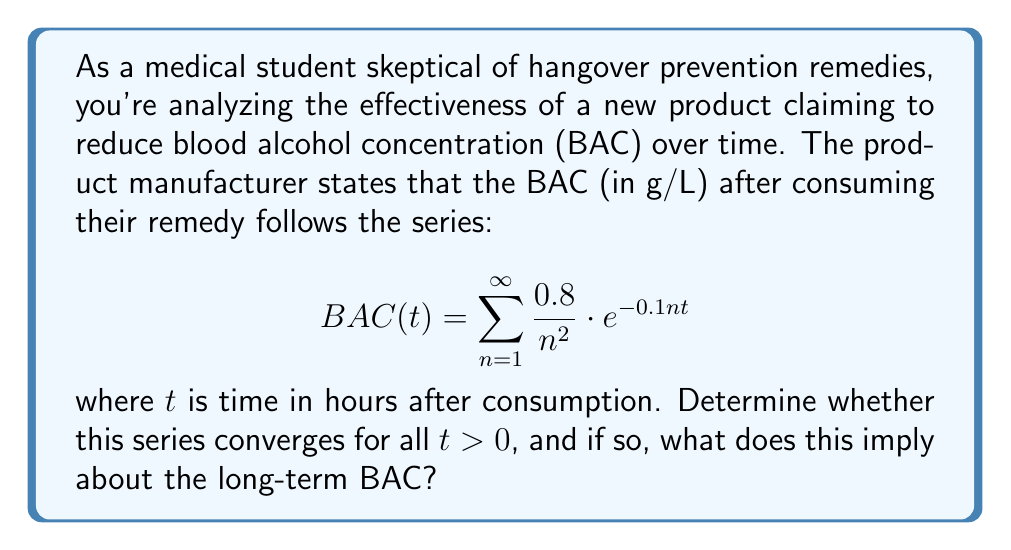Could you help me with this problem? Let's approach this step-by-step:

1) First, we need to check if the series converges for all $t > 0$. We can use the comparison test.

2) Observe that for any $t > 0$:
   
   $$0 < e^{-0.1nt} \leq 1$$

3) Therefore, we can compare our series with:
   
   $$\sum_{n=1}^{\infty} \frac{0.8}{n^2}$$

4) This is a p-series with $p = 2 > 1$, which is known to converge. Its sum is actually $\frac{\pi^2}{6}$.

5) By the comparison test, since $\frac{0.8}{n^2} \cdot e^{-0.1nt} \leq \frac{0.8}{n^2}$ for all $n$ and $t > 0$, and $\sum_{n=1}^{\infty} \frac{0.8}{n^2}$ converges, our original series must also converge for all $t > 0$.

6) The convergence of this series implies that the BAC has a finite value for any time $t > 0$.

7) As $t \to \infty$, $e^{-0.1nt} \to 0$ for all $n$, so each term in the series approaches zero.

8) This means that as $t \to \infty$, $BAC(t) \to 0$.
Answer: The series converges for all $t > 0$, implying BAC approaches 0 as time approaches infinity. 